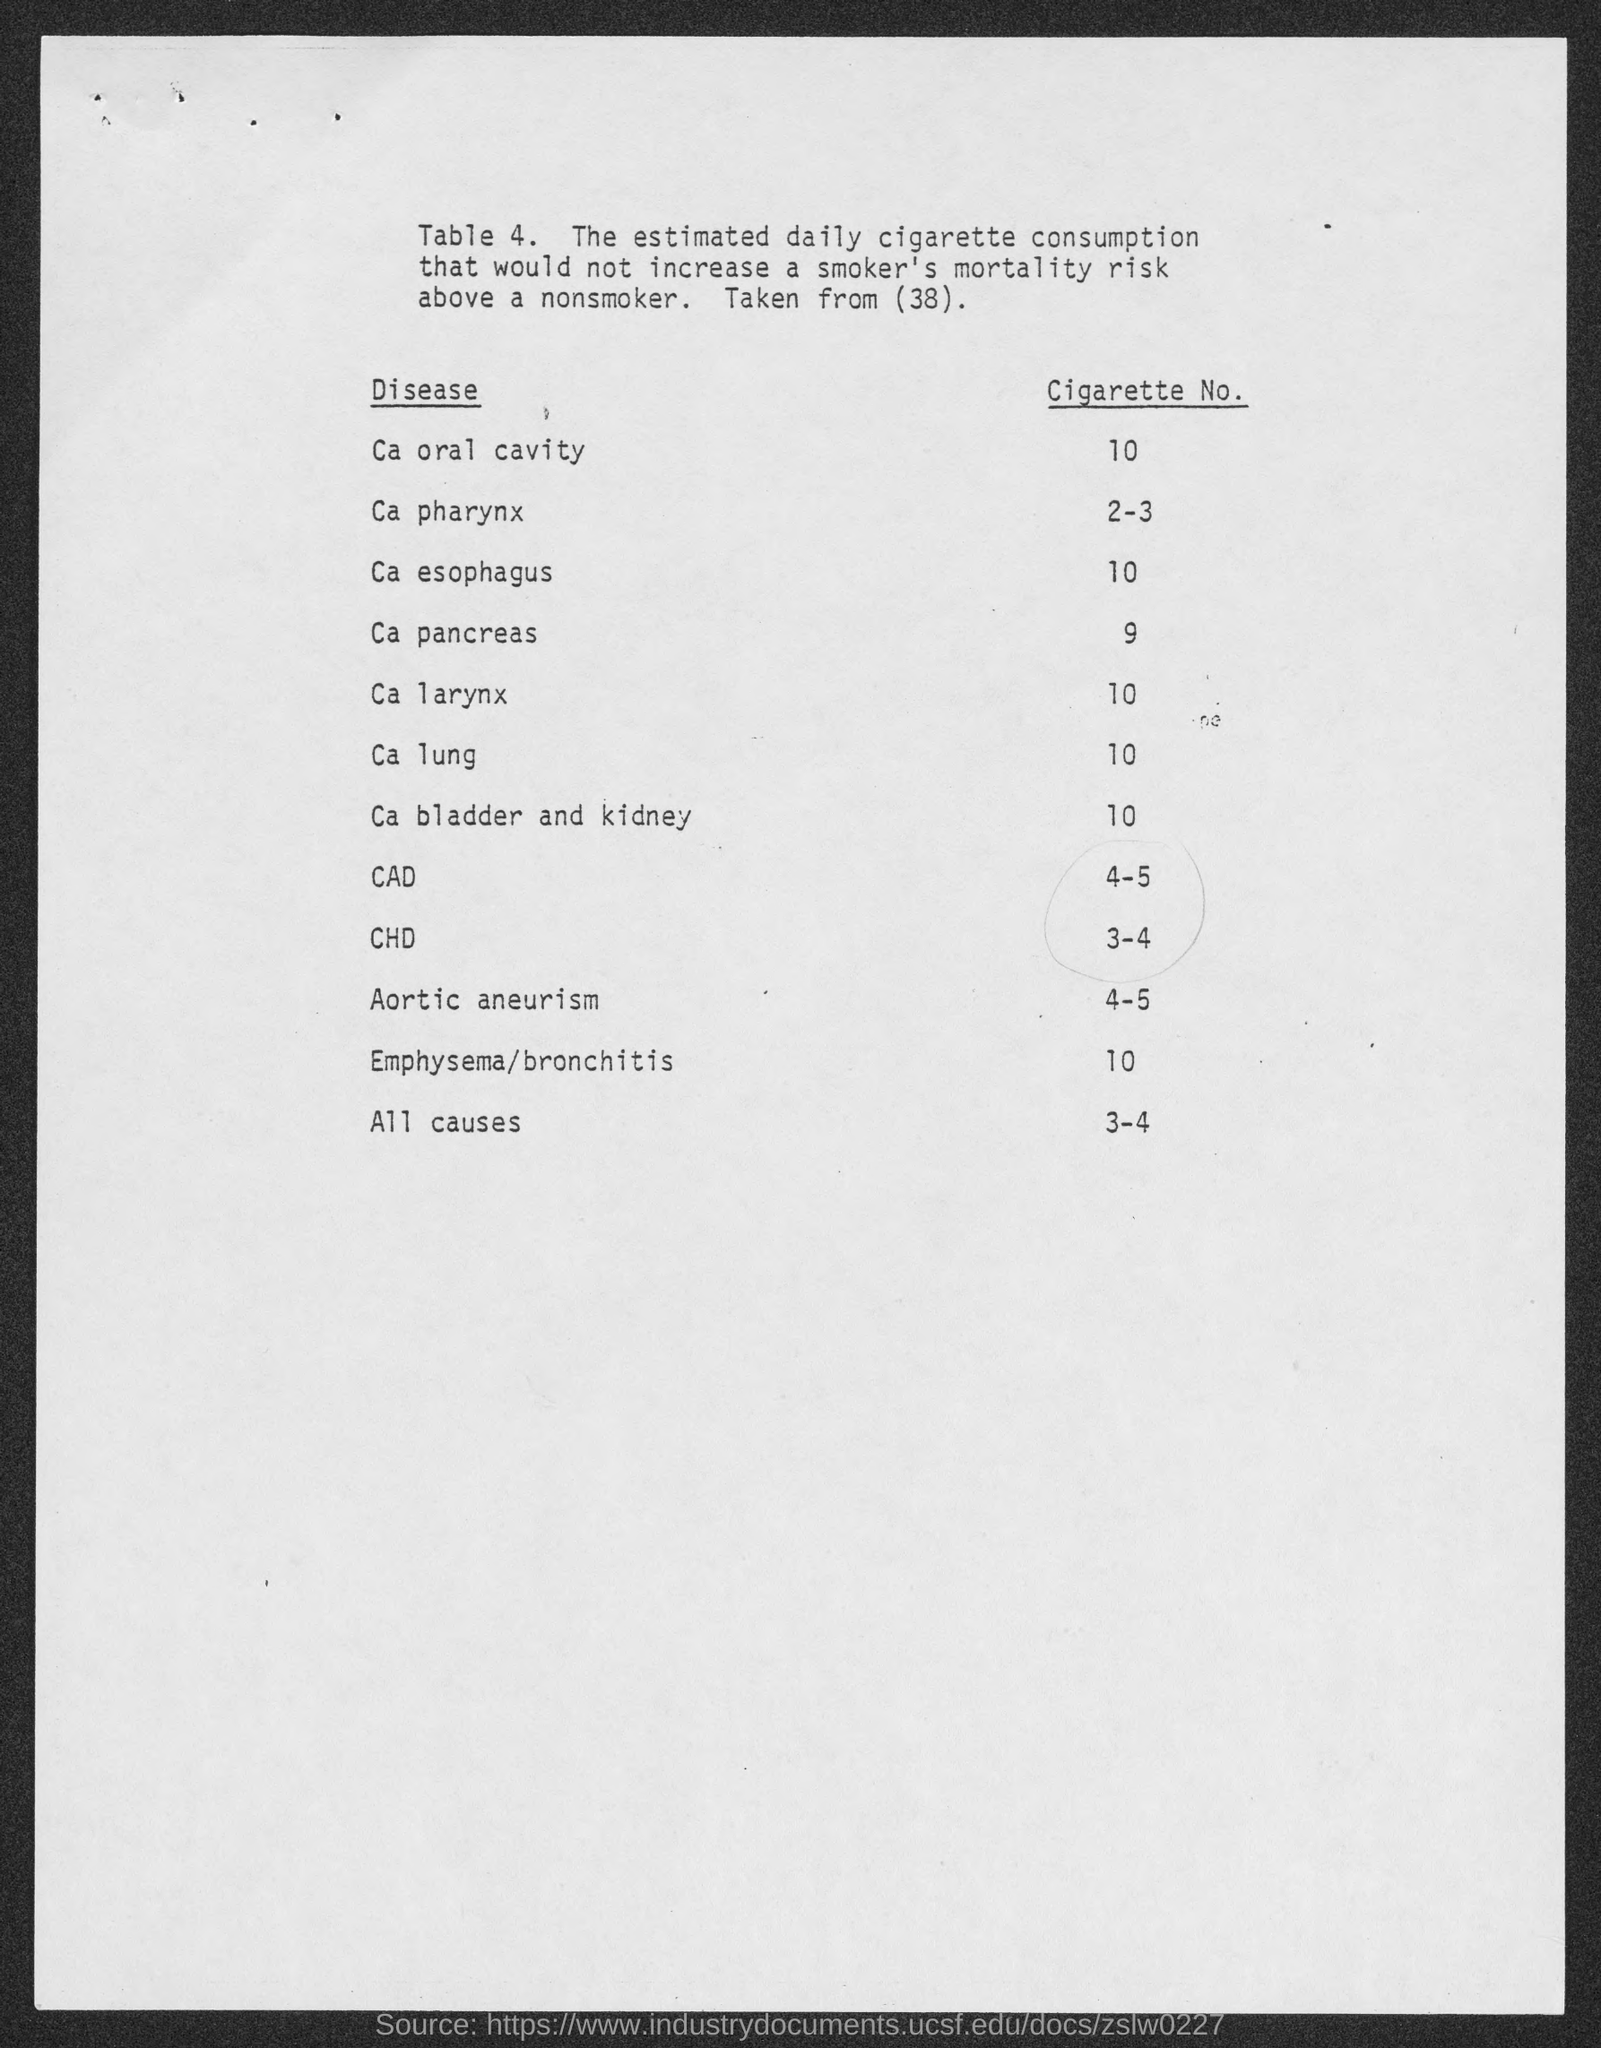Point out several critical features in this image. The disease associated with cigarette number 9 is called "Cancer of the Pancreas. The cigarette number for the ca pharynx as mentioned in the given table is 2-3. The cigarette number for the CAD as mentioned in the given table is 4-5. The cigarette number for the Ca Lung cigarette brand mentioned in the table is 10. The name of the disease caused by smoking cigarettes number 2-3 is oral pharynx cancer. 